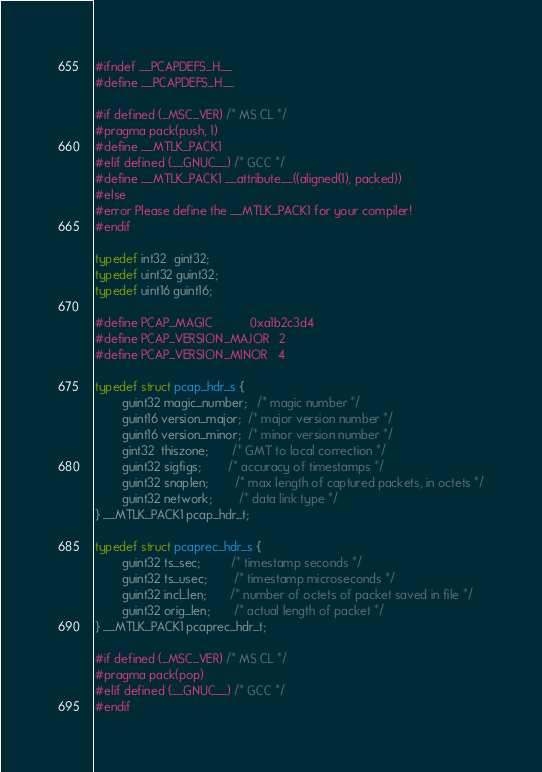Convert code to text. <code><loc_0><loc_0><loc_500><loc_500><_C_>#ifndef __PCAPDEFS_H__
#define __PCAPDEFS_H__

#if defined (_MSC_VER) /* MS CL */
#pragma pack(push, 1)
#define __MTLK_PACK1
#elif defined (__GNUC__) /* GCC */
#define __MTLK_PACK1 __attribute__((aligned(1), packed))
#else
#error Please define the __MTLK_PACK1 for your compiler!
#endif

typedef int32  gint32;
typedef uint32 guint32;
typedef uint16 guint16;

#define PCAP_MAGIC           0xa1b2c3d4
#define PCAP_VERSION_MAJOR   2
#define PCAP_VERSION_MINOR   4

typedef struct pcap_hdr_s {
        guint32 magic_number;   /* magic number */
        guint16 version_major;  /* major version number */
        guint16 version_minor;  /* minor version number */
        gint32  thiszone;       /* GMT to local correction */
        guint32 sigfigs;        /* accuracy of timestamps */
        guint32 snaplen;        /* max length of captured packets, in octets */
        guint32 network;        /* data link type */
} __MTLK_PACK1 pcap_hdr_t;

typedef struct pcaprec_hdr_s {
        guint32 ts_sec;         /* timestamp seconds */
        guint32 ts_usec;        /* timestamp microseconds */
        guint32 incl_len;       /* number of octets of packet saved in file */
        guint32 orig_len;       /* actual length of packet */
} __MTLK_PACK1 pcaprec_hdr_t;

#if defined (_MSC_VER) /* MS CL */
#pragma pack(pop)
#elif defined (__GNUC__) /* GCC */
#endif</code> 